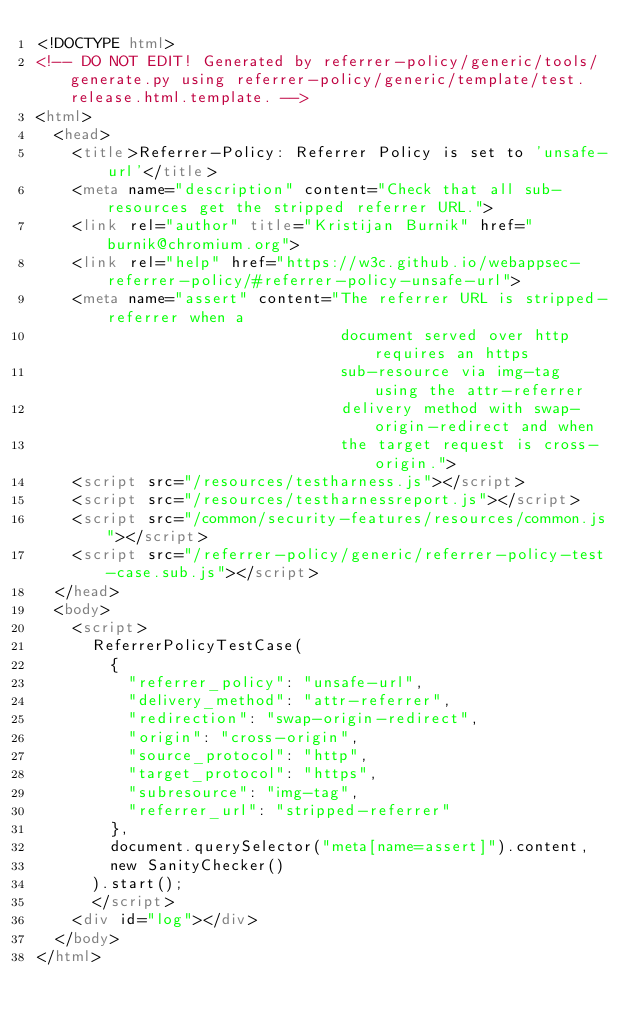Convert code to text. <code><loc_0><loc_0><loc_500><loc_500><_HTML_><!DOCTYPE html>
<!-- DO NOT EDIT! Generated by referrer-policy/generic/tools/generate.py using referrer-policy/generic/template/test.release.html.template. -->
<html>
  <head>
    <title>Referrer-Policy: Referrer Policy is set to 'unsafe-url'</title>
    <meta name="description" content="Check that all sub-resources get the stripped referrer URL.">
    <link rel="author" title="Kristijan Burnik" href="burnik@chromium.org">
    <link rel="help" href="https://w3c.github.io/webappsec-referrer-policy/#referrer-policy-unsafe-url">
    <meta name="assert" content="The referrer URL is stripped-referrer when a
                                 document served over http requires an https
                                 sub-resource via img-tag using the attr-referrer
                                 delivery method with swap-origin-redirect and when
                                 the target request is cross-origin.">
    <script src="/resources/testharness.js"></script>
    <script src="/resources/testharnessreport.js"></script>
    <script src="/common/security-features/resources/common.js"></script>
    <script src="/referrer-policy/generic/referrer-policy-test-case.sub.js"></script>
  </head>
  <body>
    <script>
      ReferrerPolicyTestCase(
        {
          "referrer_policy": "unsafe-url",
          "delivery_method": "attr-referrer",
          "redirection": "swap-origin-redirect",
          "origin": "cross-origin",
          "source_protocol": "http",
          "target_protocol": "https",
          "subresource": "img-tag",
          "referrer_url": "stripped-referrer"
        },
        document.querySelector("meta[name=assert]").content,
        new SanityChecker()
      ).start();
      </script>
    <div id="log"></div>
  </body>
</html>
</code> 